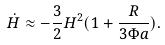Convert formula to latex. <formula><loc_0><loc_0><loc_500><loc_500>\dot { H } \approx - \frac { 3 } { 2 } H ^ { 2 } ( 1 + \frac { R } { 3 \Phi a } ) .</formula> 